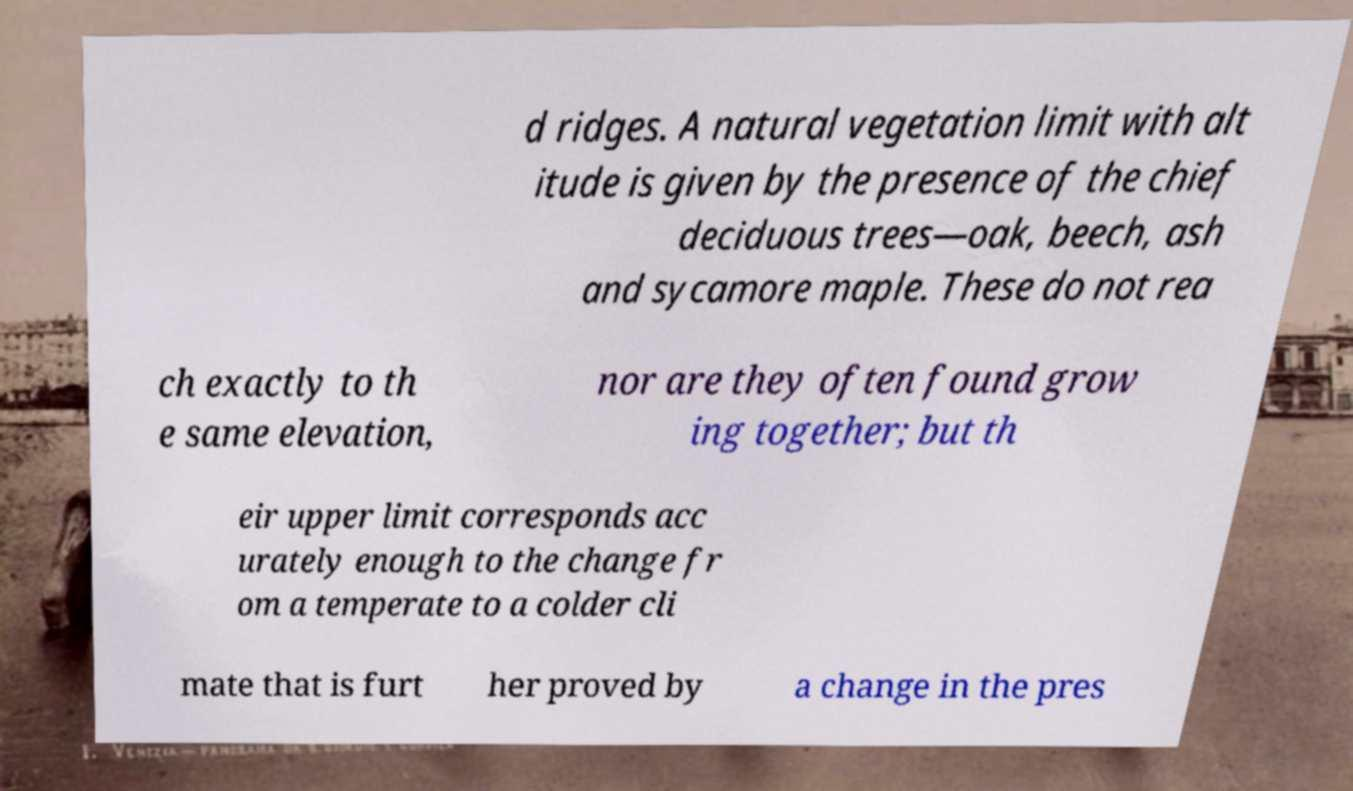Please read and relay the text visible in this image. What does it say? d ridges. A natural vegetation limit with alt itude is given by the presence of the chief deciduous trees—oak, beech, ash and sycamore maple. These do not rea ch exactly to th e same elevation, nor are they often found grow ing together; but th eir upper limit corresponds acc urately enough to the change fr om a temperate to a colder cli mate that is furt her proved by a change in the pres 